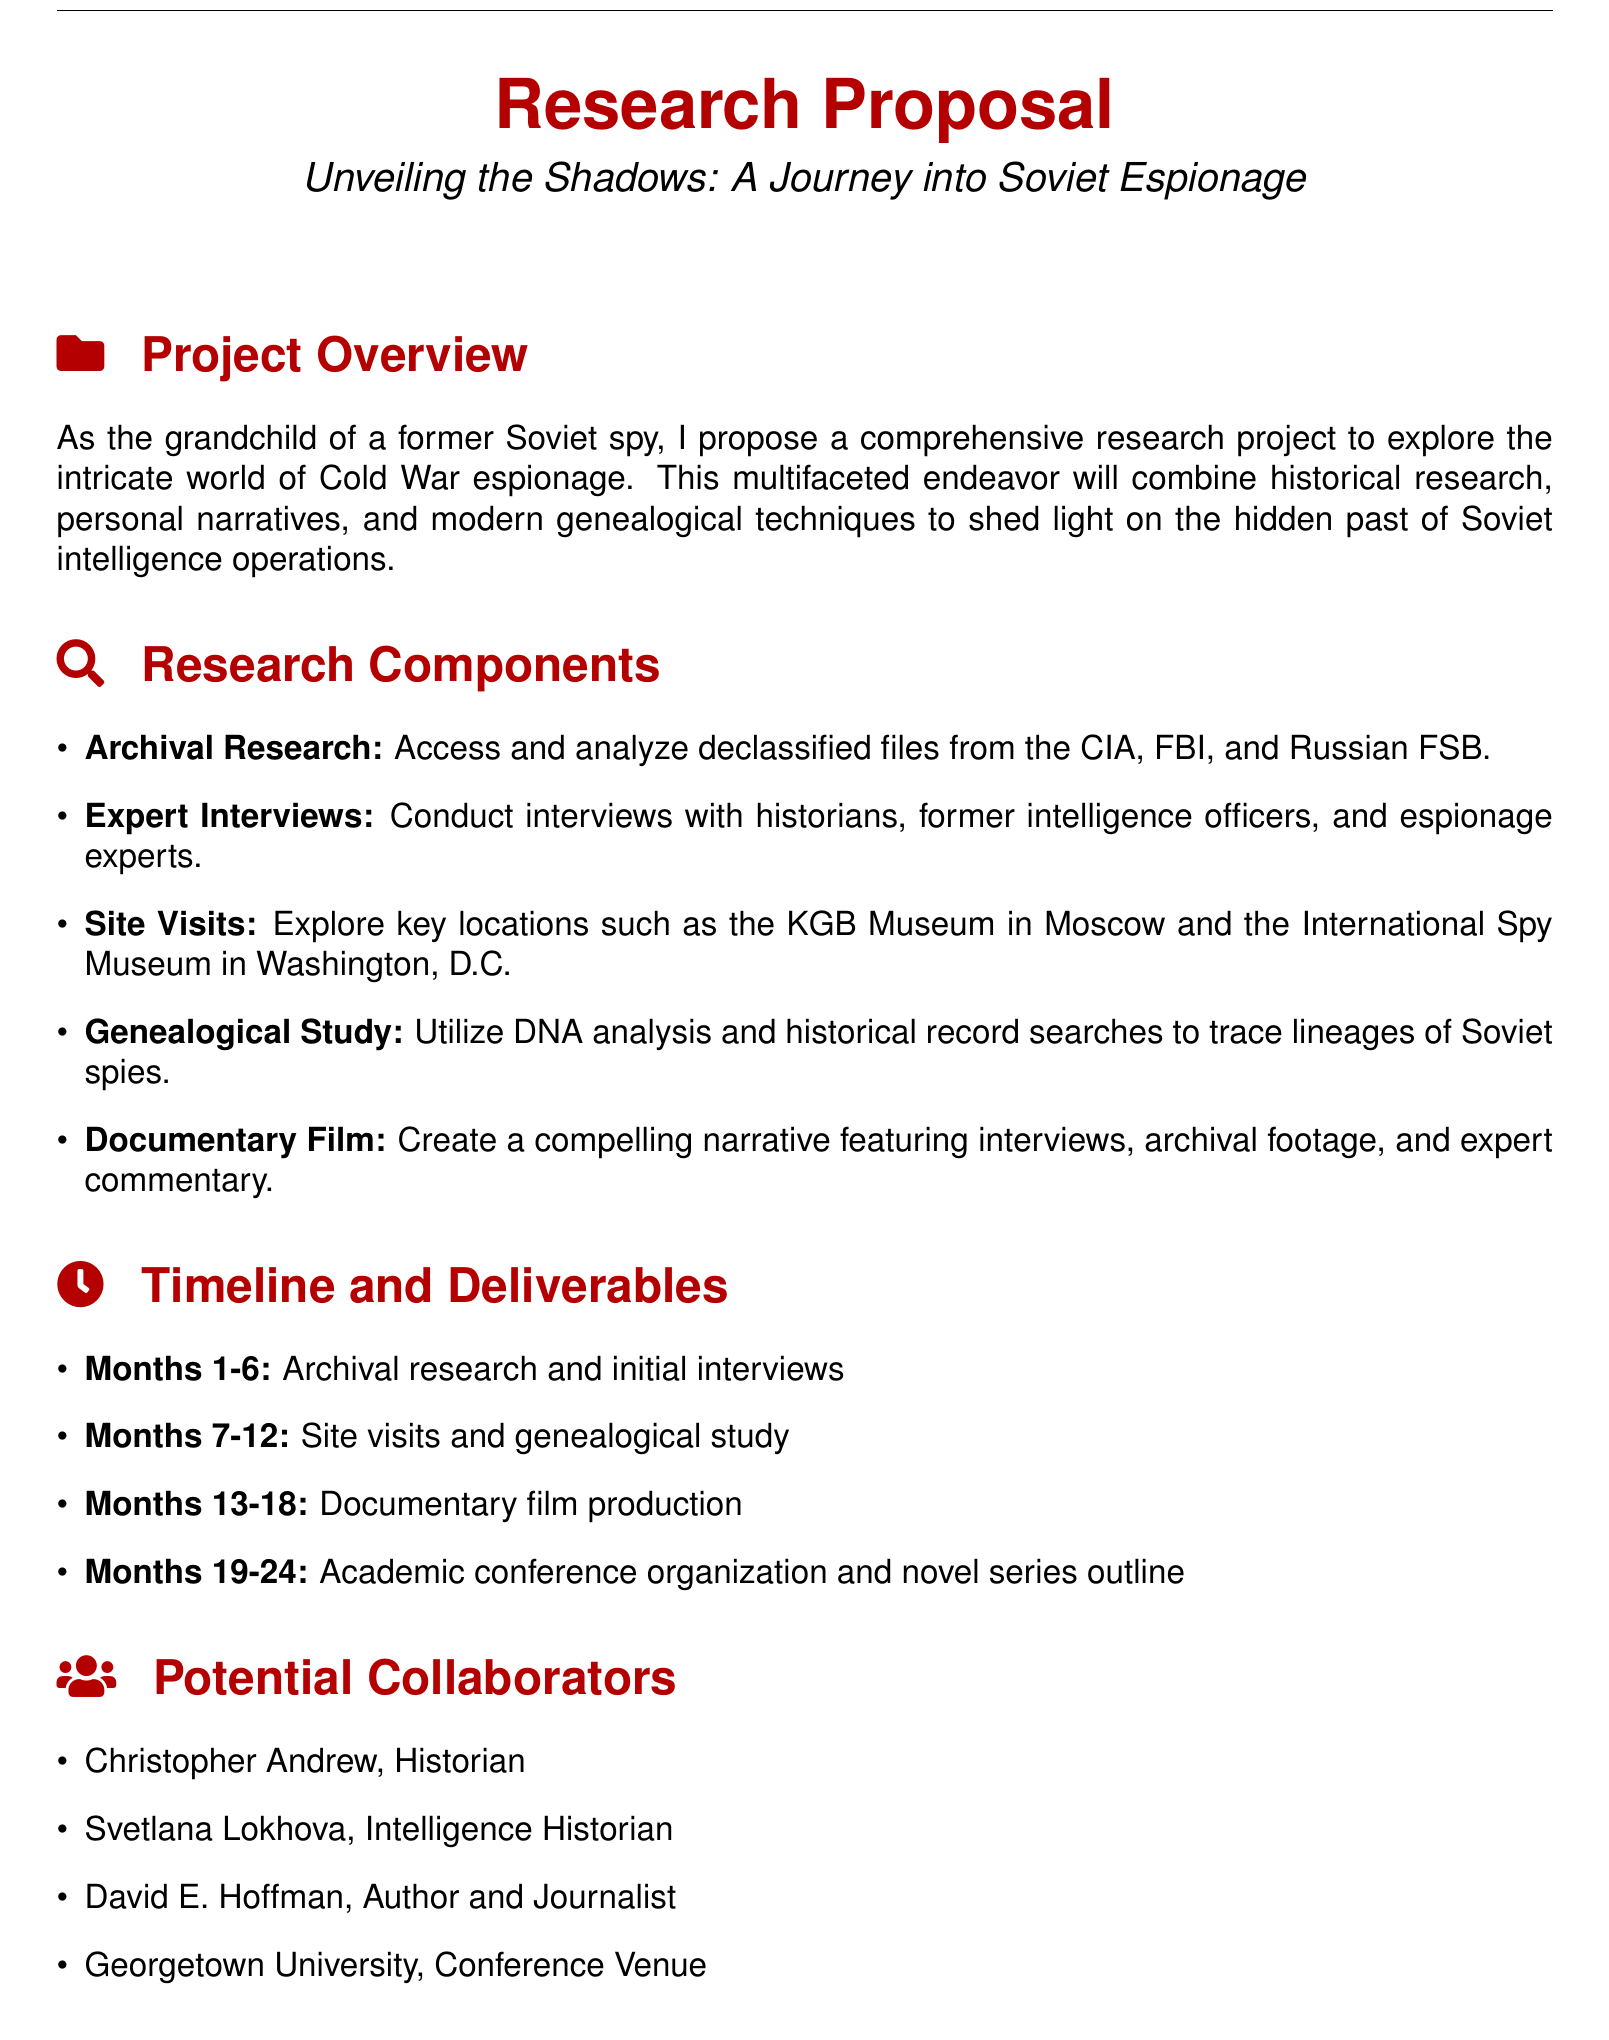What is the title of the proposal? The title of the proposal is prominently displayed at the top of the document.
Answer: Unveiling the Shadows: A Journey into Soviet Espionage Who is the proposed project for? The document specifies that the proposal is made by the grandchild of a former Soviet spy.
Answer: The grandchild of a former Soviet spy What is the first research component mentioned? The first item listed under research components is the starting point for the proposed research activities.
Answer: Archival Research How many months are allocated for documentary film production? The timeline indicates how many months are expected for producing the documentary film as part of the project.
Answer: 6 months What is the expected outcome related to genealogy? The expected outcomes include various deliverables, one of which is related to the genealogical study mentioned.
Answer: Published genealogy study Who is listed as a potential collaborator and a historian? The document provides names of potential collaborators and specifies their areas of expertise.
Answer: Christopher Andrew In which month does the project begin its archival research? The timeline outlines the start of various phases of the project.
Answer: Month 1 What type of event is proposed to discuss espionage? The proposal includes an academic event that will gather experts and participants in the field of espionage.
Answer: Academic conference 